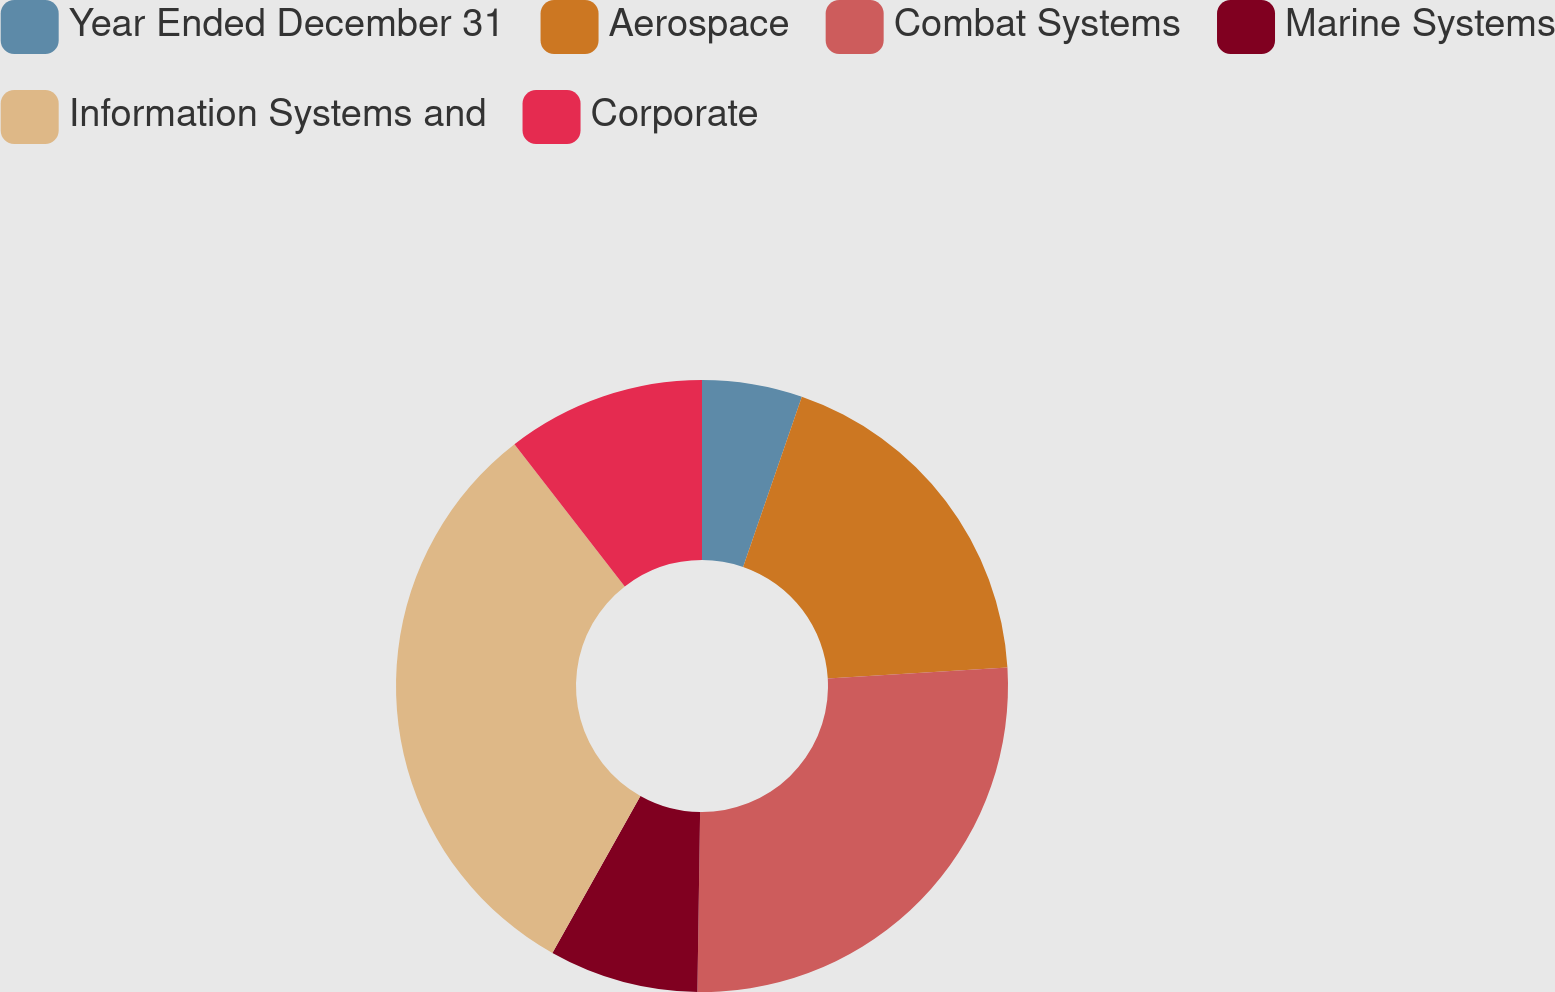<chart> <loc_0><loc_0><loc_500><loc_500><pie_chart><fcel>Year Ended December 31<fcel>Aerospace<fcel>Combat Systems<fcel>Marine Systems<fcel>Information Systems and<fcel>Corporate<nl><fcel>5.29%<fcel>18.75%<fcel>26.2%<fcel>7.89%<fcel>31.37%<fcel>10.5%<nl></chart> 